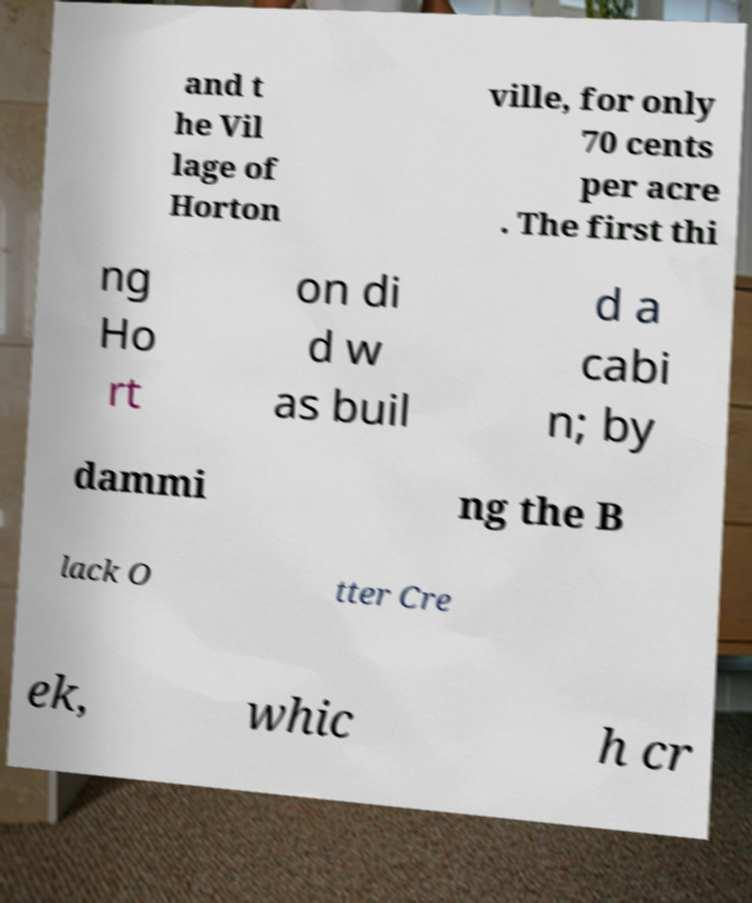I need the written content from this picture converted into text. Can you do that? and t he Vil lage of Horton ville, for only 70 cents per acre . The first thi ng Ho rt on di d w as buil d a cabi n; by dammi ng the B lack O tter Cre ek, whic h cr 